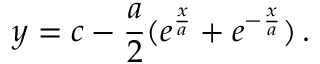<formula> <loc_0><loc_0><loc_500><loc_500>y = c - \frac { a } { 2 } ( e ^ { \frac { x } { a } } + e ^ { - \frac { x } { a } } ) \, .</formula> 